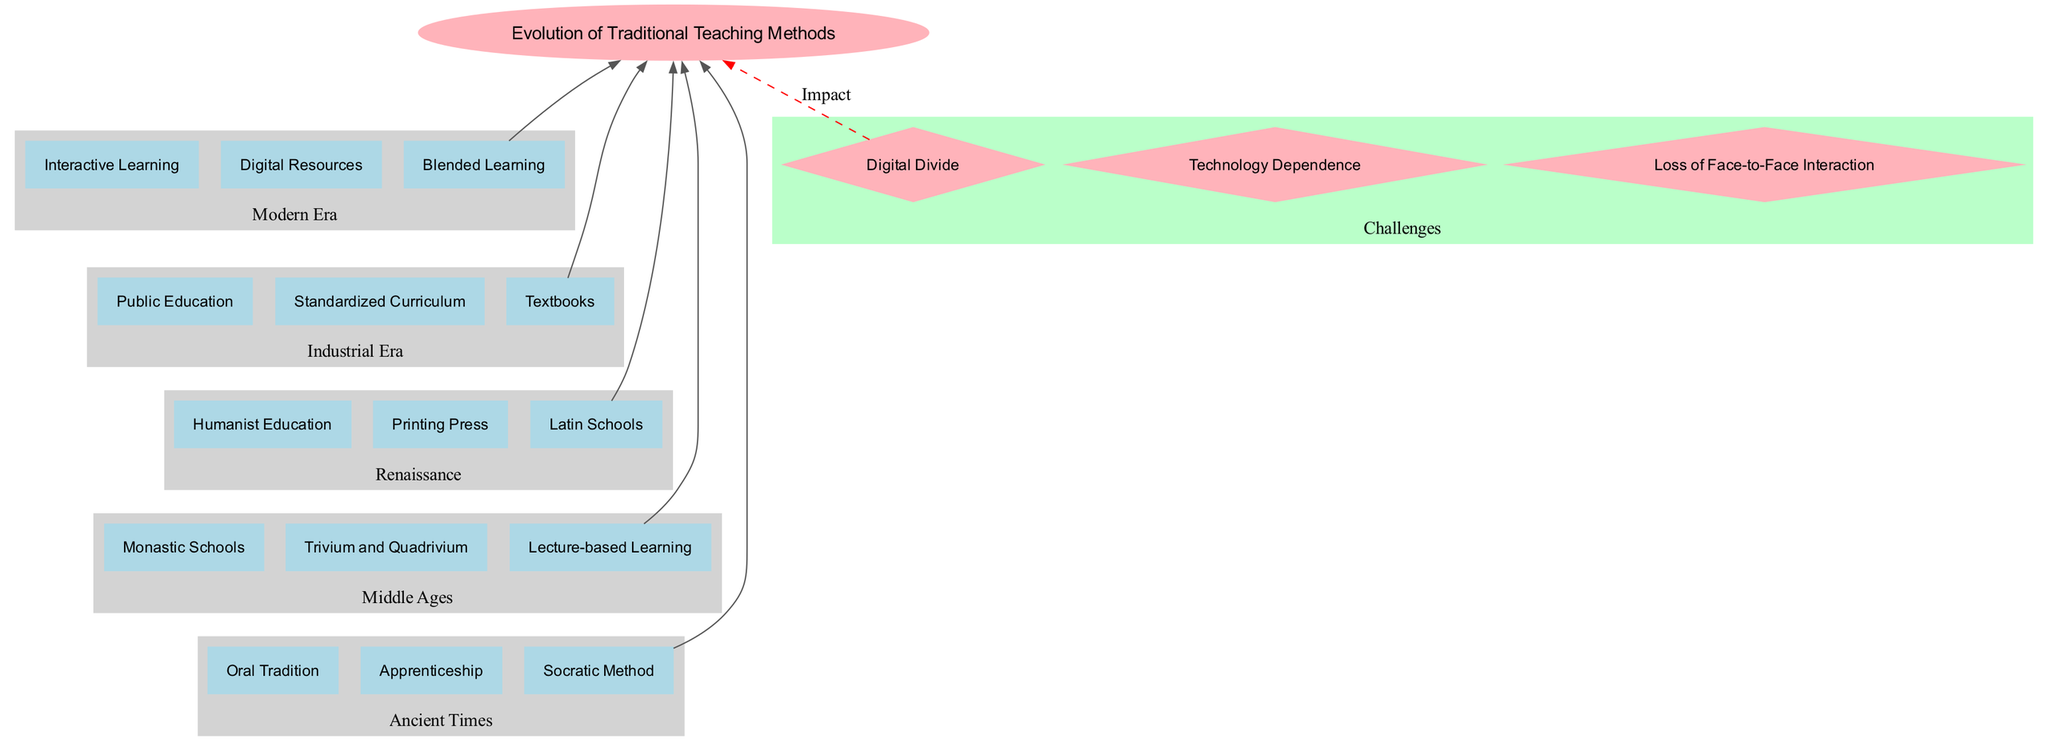What is the root of the diagram? The root of the diagram represents the overarching theme, which is the "Evolution of Traditional Teaching Methods." This information can be quickly identified at the top of the diagram and serves as a summary of the content below it.
Answer: Evolution of Traditional Teaching Methods How many eras of teaching methods are depicted in the diagram? The diagram includes five distinct eras that detail the evolution of teaching methods, making it essential to count each branch that represents an era. These eras are Ancient Times, Middle Ages, Renaissance, Industrial Era, and Modern Era.
Answer: 5 What learning method is associated with Ancient Times? The elements listed under the "Ancient Times" branch include "Oral Tradition," "Apprenticeship," and "Socratic Method." Any of these could be acceptable answers, but taking the first element gives a straightforward answer.
Answer: Oral Tradition What is the last teaching method in the Industrial Era branch? By examining the "Industrial Era" branch, we can identify the last teaching method listed, which is "Textbooks," as it is positioned last among the three methods.
Answer: Textbooks What relationship exists between Modern Era and challenges? The diagram features a dashed edge connecting the last element in the Modern Era branch to the Challenges cluster, indicating that modern teaching methods are either impacted by or contribute to the challenges depicted.
Answer: Impact Which element follows 'Lecture-based Learning' in the diagram? The "Lecture-based Learning" element appears in the "Middle Ages" branch, and by following the arrows into the subsequent branch, it connects directly to the first element in "Renaissance," which is "Humanist Education."
Answer: Humanist Education How many challenges are identified in the diagram? The diagram lists three challenges that relate to the evolution of traditional teaching methods, as indicated in the Challenges cluster at the bottom. Counting these gives the final answer.
Answer: 3 Name one method introduced during the Renaissance. Under the "Renaissance" branch, the teaching methods include "Humanist Education," "Printing Press," and "Latin Schools." Any of these would suffice as an answer, but selecting the first element gives a clear response.
Answer: Humanist Education Which teaching method uses technology according to the diagram? In the "Modern Era," "Digital Resources" is explicitly mentioned as a teaching method that utilizes technology, as suggested by the context and placement within this era.
Answer: Digital Resources 